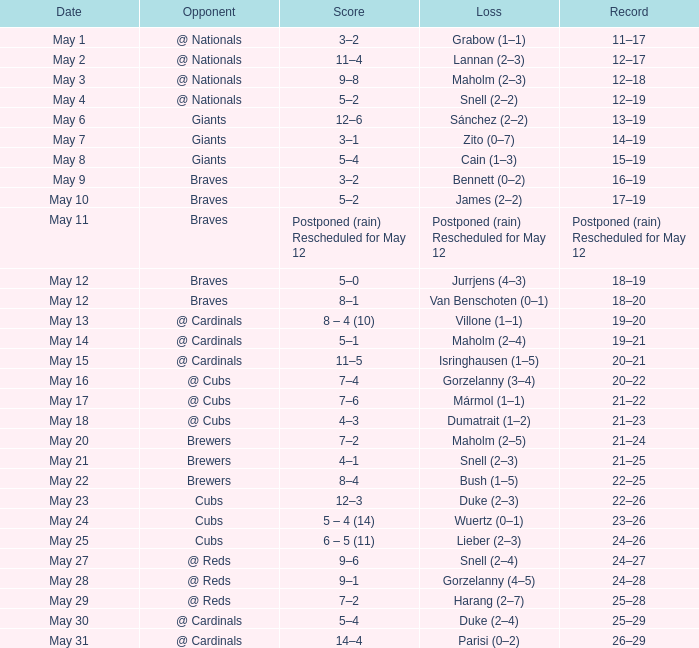What is the date of the game in which bush experienced a 1-5 loss? May 22. 